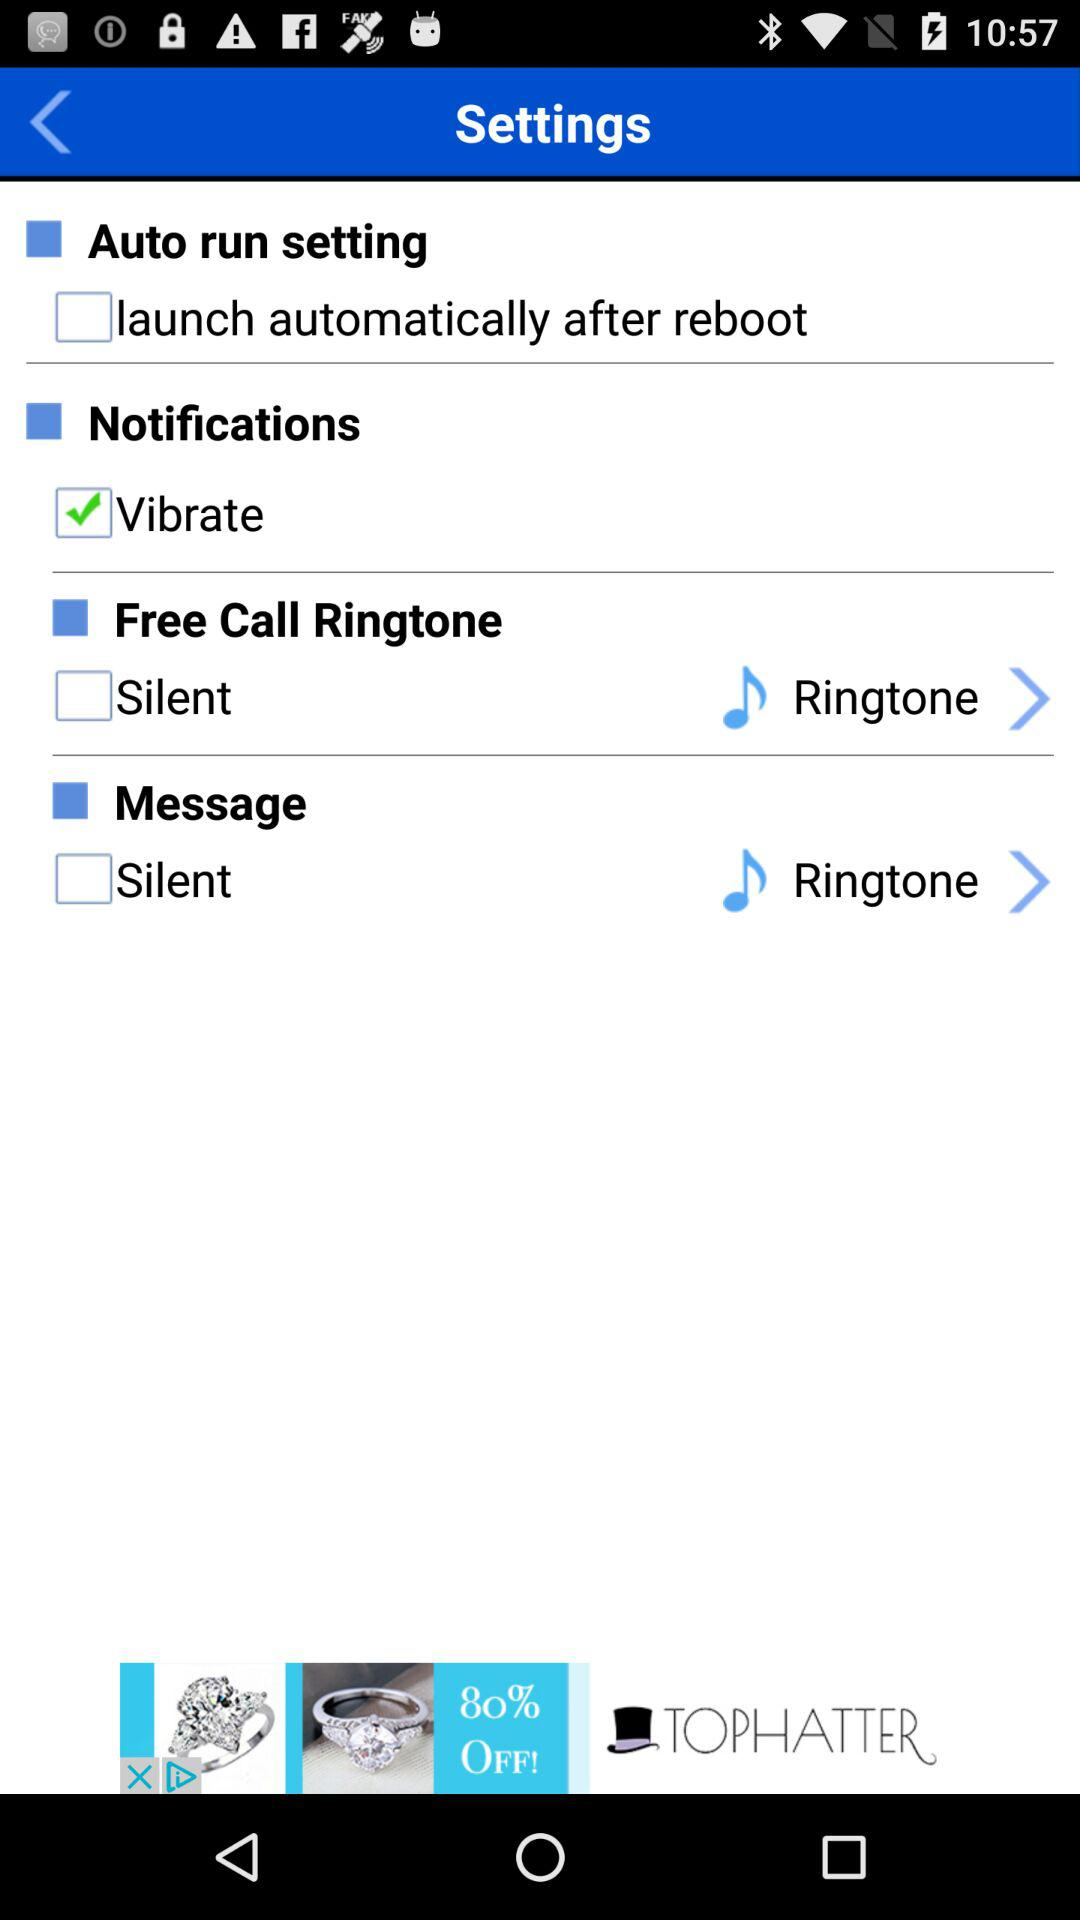What is the status of the vibrate notification setting? The status is on. 